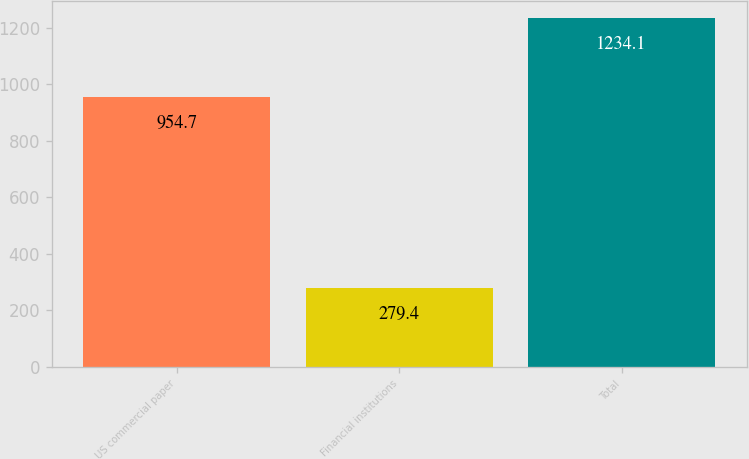<chart> <loc_0><loc_0><loc_500><loc_500><bar_chart><fcel>US commercial paper<fcel>Financial institutions<fcel>Total<nl><fcel>954.7<fcel>279.4<fcel>1234.1<nl></chart> 